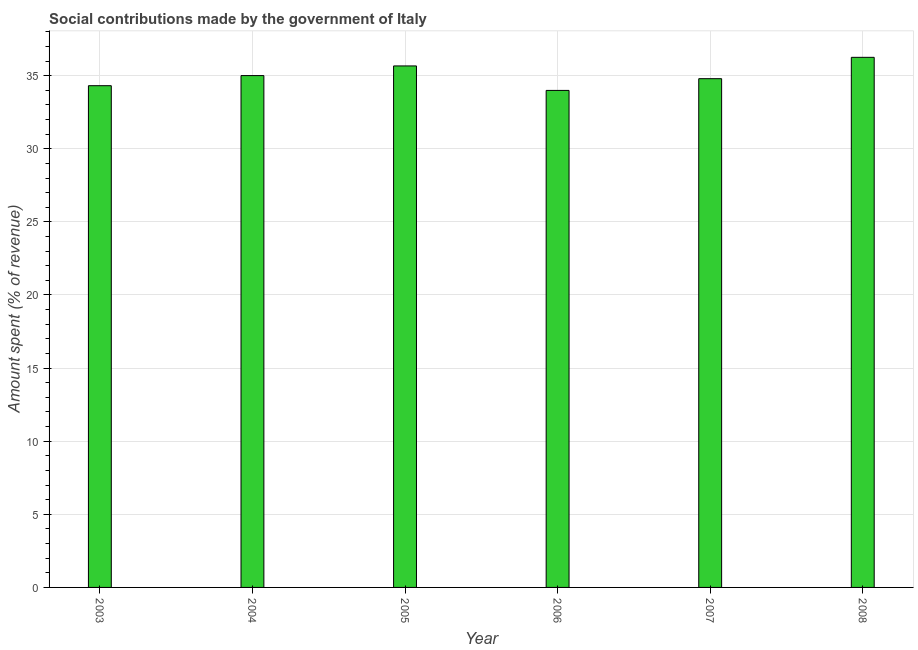Does the graph contain grids?
Make the answer very short. Yes. What is the title of the graph?
Offer a terse response. Social contributions made by the government of Italy. What is the label or title of the Y-axis?
Keep it short and to the point. Amount spent (% of revenue). What is the amount spent in making social contributions in 2008?
Make the answer very short. 36.25. Across all years, what is the maximum amount spent in making social contributions?
Offer a very short reply. 36.25. Across all years, what is the minimum amount spent in making social contributions?
Ensure brevity in your answer.  33.99. In which year was the amount spent in making social contributions maximum?
Your answer should be compact. 2008. What is the sum of the amount spent in making social contributions?
Ensure brevity in your answer.  210.02. What is the difference between the amount spent in making social contributions in 2005 and 2006?
Provide a short and direct response. 1.67. What is the average amount spent in making social contributions per year?
Keep it short and to the point. 35. What is the median amount spent in making social contributions?
Provide a succinct answer. 34.9. What is the difference between the highest and the second highest amount spent in making social contributions?
Offer a very short reply. 0.59. What is the difference between the highest and the lowest amount spent in making social contributions?
Your answer should be very brief. 2.26. What is the difference between two consecutive major ticks on the Y-axis?
Offer a terse response. 5. What is the Amount spent (% of revenue) of 2003?
Your answer should be very brief. 34.31. What is the Amount spent (% of revenue) in 2004?
Keep it short and to the point. 35. What is the Amount spent (% of revenue) in 2005?
Provide a succinct answer. 35.67. What is the Amount spent (% of revenue) in 2006?
Offer a very short reply. 33.99. What is the Amount spent (% of revenue) of 2007?
Offer a very short reply. 34.79. What is the Amount spent (% of revenue) in 2008?
Your answer should be compact. 36.25. What is the difference between the Amount spent (% of revenue) in 2003 and 2004?
Offer a terse response. -0.69. What is the difference between the Amount spent (% of revenue) in 2003 and 2005?
Provide a succinct answer. -1.35. What is the difference between the Amount spent (% of revenue) in 2003 and 2006?
Offer a terse response. 0.32. What is the difference between the Amount spent (% of revenue) in 2003 and 2007?
Offer a terse response. -0.48. What is the difference between the Amount spent (% of revenue) in 2003 and 2008?
Ensure brevity in your answer.  -1.94. What is the difference between the Amount spent (% of revenue) in 2004 and 2005?
Your answer should be very brief. -0.66. What is the difference between the Amount spent (% of revenue) in 2004 and 2006?
Your response must be concise. 1.01. What is the difference between the Amount spent (% of revenue) in 2004 and 2007?
Your answer should be very brief. 0.21. What is the difference between the Amount spent (% of revenue) in 2004 and 2008?
Provide a succinct answer. -1.25. What is the difference between the Amount spent (% of revenue) in 2005 and 2006?
Your response must be concise. 1.67. What is the difference between the Amount spent (% of revenue) in 2005 and 2007?
Provide a short and direct response. 0.87. What is the difference between the Amount spent (% of revenue) in 2005 and 2008?
Keep it short and to the point. -0.59. What is the difference between the Amount spent (% of revenue) in 2006 and 2007?
Provide a succinct answer. -0.8. What is the difference between the Amount spent (% of revenue) in 2006 and 2008?
Your answer should be compact. -2.26. What is the difference between the Amount spent (% of revenue) in 2007 and 2008?
Your answer should be very brief. -1.46. What is the ratio of the Amount spent (% of revenue) in 2003 to that in 2004?
Give a very brief answer. 0.98. What is the ratio of the Amount spent (% of revenue) in 2003 to that in 2008?
Your answer should be very brief. 0.95. What is the ratio of the Amount spent (% of revenue) in 2004 to that in 2005?
Provide a short and direct response. 0.98. What is the ratio of the Amount spent (% of revenue) in 2004 to that in 2006?
Ensure brevity in your answer.  1.03. What is the ratio of the Amount spent (% of revenue) in 2004 to that in 2007?
Your response must be concise. 1.01. What is the ratio of the Amount spent (% of revenue) in 2004 to that in 2008?
Provide a succinct answer. 0.97. What is the ratio of the Amount spent (% of revenue) in 2005 to that in 2006?
Offer a terse response. 1.05. What is the ratio of the Amount spent (% of revenue) in 2005 to that in 2007?
Give a very brief answer. 1.02. What is the ratio of the Amount spent (% of revenue) in 2006 to that in 2007?
Offer a terse response. 0.98. What is the ratio of the Amount spent (% of revenue) in 2006 to that in 2008?
Give a very brief answer. 0.94. 